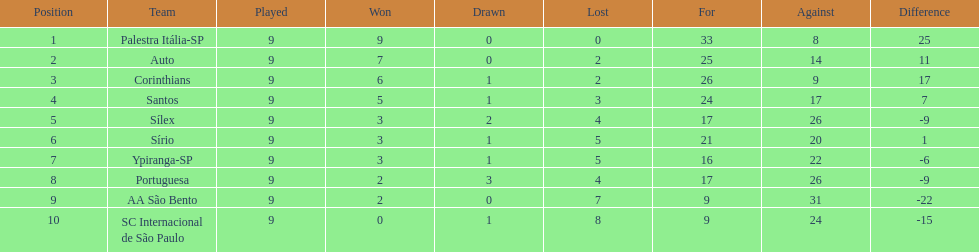What are all the teams? Palestra Itália-SP, Auto, Corinthians, Santos, Sílex, Sírio, Ypiranga-SP, Portuguesa, AA São Bento, SC Internacional de São Paulo. How many times did each team lose? 0, 2, 2, 3, 4, 5, 5, 4, 7, 8. And which team never lost? Palestra Itália-SP. 